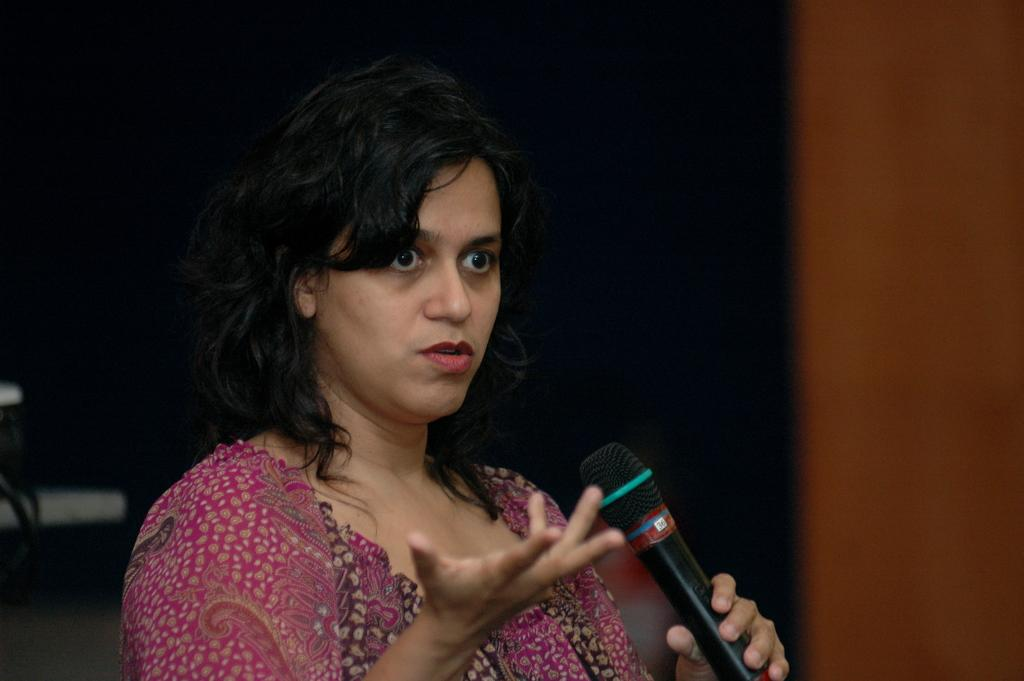Who is the main subject in the image? There is a woman in the image. What is the woman wearing? The woman is wearing a pink dress. What object is the woman holding in the image? The woman is holding a microphone (mike). What type of paste is the woman using to stick the microphone to the wall in the image? There is no paste or wall present in the image, and the woman is not using any paste to stick the microphone to anything. 